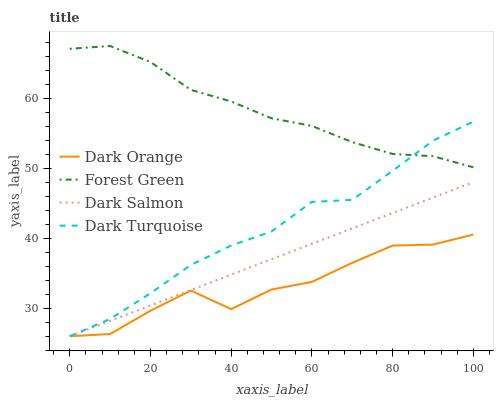Does Dark Orange have the minimum area under the curve?
Answer yes or no. Yes. Does Forest Green have the maximum area under the curve?
Answer yes or no. Yes. Does Dark Salmon have the minimum area under the curve?
Answer yes or no. No. Does Dark Salmon have the maximum area under the curve?
Answer yes or no. No. Is Dark Salmon the smoothest?
Answer yes or no. Yes. Is Dark Orange the roughest?
Answer yes or no. Yes. Is Forest Green the smoothest?
Answer yes or no. No. Is Forest Green the roughest?
Answer yes or no. No. Does Dark Orange have the lowest value?
Answer yes or no. Yes. Does Forest Green have the lowest value?
Answer yes or no. No. Does Forest Green have the highest value?
Answer yes or no. Yes. Does Dark Salmon have the highest value?
Answer yes or no. No. Is Dark Orange less than Forest Green?
Answer yes or no. Yes. Is Forest Green greater than Dark Orange?
Answer yes or no. Yes. Does Dark Salmon intersect Dark Orange?
Answer yes or no. Yes. Is Dark Salmon less than Dark Orange?
Answer yes or no. No. Is Dark Salmon greater than Dark Orange?
Answer yes or no. No. Does Dark Orange intersect Forest Green?
Answer yes or no. No. 